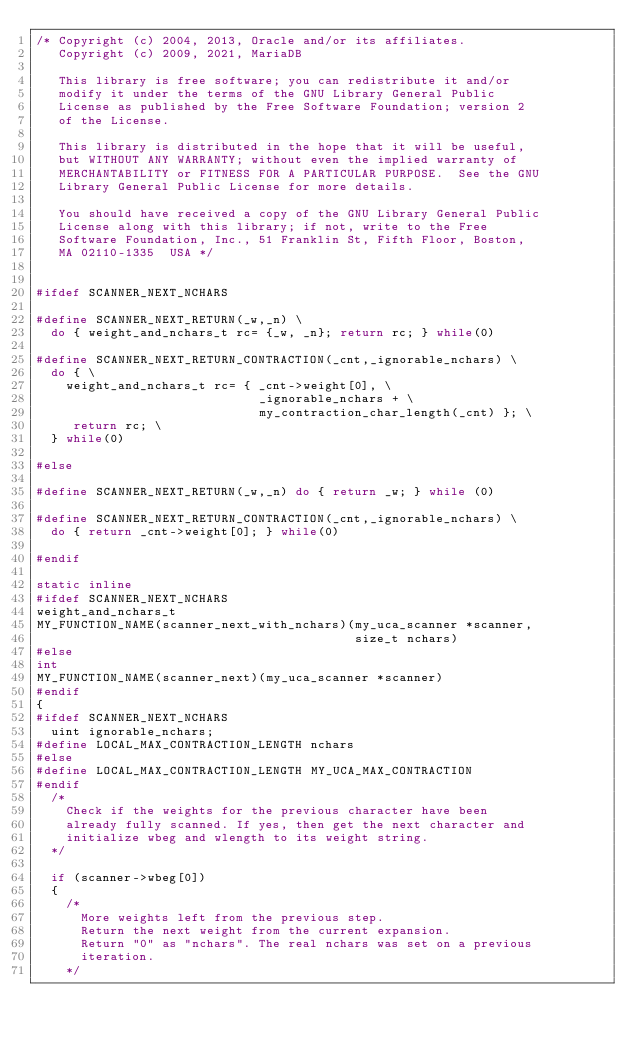<code> <loc_0><loc_0><loc_500><loc_500><_C++_>/* Copyright (c) 2004, 2013, Oracle and/or its affiliates.
   Copyright (c) 2009, 2021, MariaDB   

   This library is free software; you can redistribute it and/or
   modify it under the terms of the GNU Library General Public
   License as published by the Free Software Foundation; version 2
   of the License.

   This library is distributed in the hope that it will be useful,
   but WITHOUT ANY WARRANTY; without even the implied warranty of
   MERCHANTABILITY or FITNESS FOR A PARTICULAR PURPOSE.  See the GNU
   Library General Public License for more details.

   You should have received a copy of the GNU Library General Public
   License along with this library; if not, write to the Free
   Software Foundation, Inc., 51 Franklin St, Fifth Floor, Boston,
   MA 02110-1335  USA */


#ifdef SCANNER_NEXT_NCHARS

#define SCANNER_NEXT_RETURN(_w,_n) \
  do { weight_and_nchars_t rc= {_w, _n}; return rc; } while(0)

#define SCANNER_NEXT_RETURN_CONTRACTION(_cnt,_ignorable_nchars) \
  do { \
    weight_and_nchars_t rc= { _cnt->weight[0], \
                              _ignorable_nchars + \
                              my_contraction_char_length(_cnt) }; \
     return rc; \
  } while(0)

#else

#define SCANNER_NEXT_RETURN(_w,_n) do { return _w; } while (0)

#define SCANNER_NEXT_RETURN_CONTRACTION(_cnt,_ignorable_nchars) \
  do { return _cnt->weight[0]; } while(0)

#endif

static inline
#ifdef SCANNER_NEXT_NCHARS
weight_and_nchars_t
MY_FUNCTION_NAME(scanner_next_with_nchars)(my_uca_scanner *scanner,
                                           size_t nchars)
#else
int
MY_FUNCTION_NAME(scanner_next)(my_uca_scanner *scanner)
#endif
{
#ifdef SCANNER_NEXT_NCHARS
  uint ignorable_nchars;
#define LOCAL_MAX_CONTRACTION_LENGTH nchars
#else
#define LOCAL_MAX_CONTRACTION_LENGTH MY_UCA_MAX_CONTRACTION
#endif
  /*
    Check if the weights for the previous character have been
    already fully scanned. If yes, then get the next character and
    initialize wbeg and wlength to its weight string.
  */

  if (scanner->wbeg[0])
  {
    /*
      More weights left from the previous step.
      Return the next weight from the current expansion.
      Return "0" as "nchars". The real nchars was set on a previous
      iteration.
    */</code> 